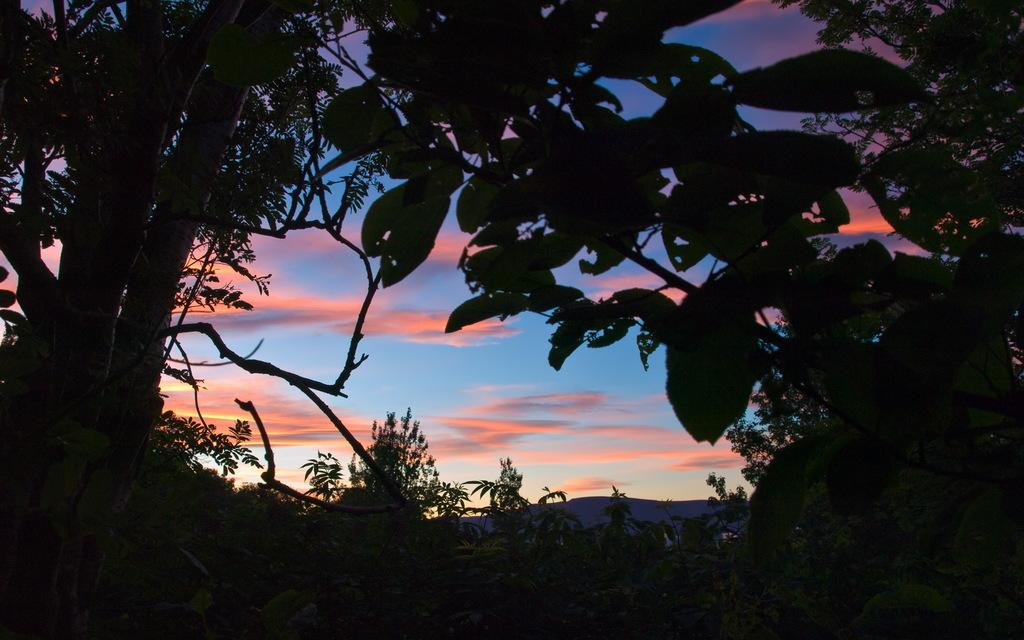What type of vegetation can be seen in the image? There are trees in the image. What part of the natural environment is visible in the image? The sky is visible in the image. What can be observed in the sky? Clouds are present in the sky. How would you describe the overall lighting in the image? The image appears to be slightly dark. What flavor of ice cream is being served to the family in the image? There is no ice cream or family present in the image; it features trees and a sky with clouds. 